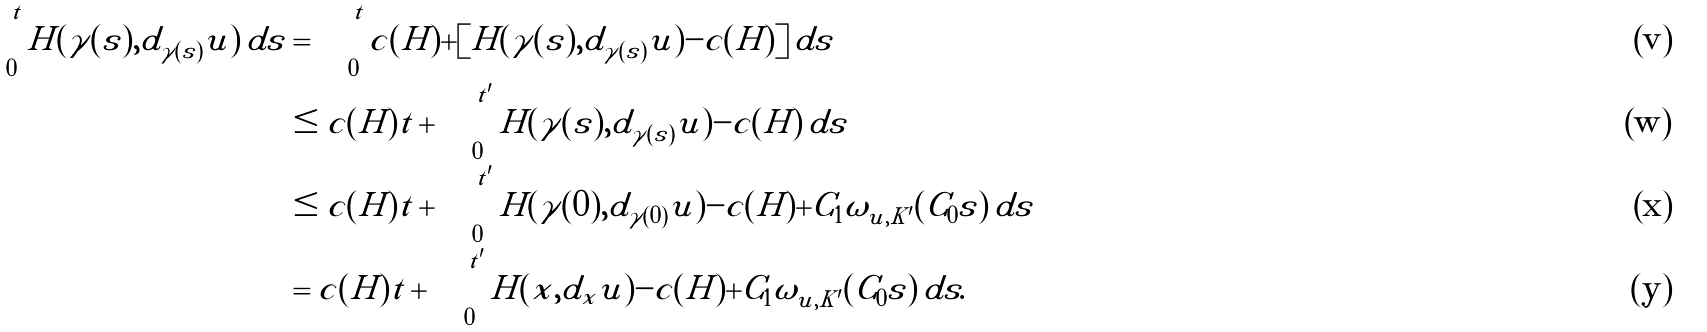Convert formula to latex. <formula><loc_0><loc_0><loc_500><loc_500>\int _ { 0 } ^ { t } H ( \gamma ( s ) , d _ { \gamma ( s ) } u ) \, d s & = \int _ { 0 } ^ { t } c ( H ) + [ H ( \gamma ( s ) , d _ { \gamma ( s ) } u ) - c ( H ) ] \, d s \\ & \leq c ( H ) t + \int _ { 0 } ^ { t ^ { \prime } } H ( \gamma ( s ) , d _ { \gamma ( s ) } u ) - c ( H ) \, d s \\ & \leq c ( H ) t + \int _ { 0 } ^ { t ^ { \prime } } H ( \gamma ( 0 ) , d _ { \gamma ( 0 ) } u ) - c ( H ) + C _ { 1 } \omega _ { u , K ^ { \prime } } ( C _ { 0 } s ) \, d s \\ & = c ( H ) t + \int _ { 0 } ^ { t ^ { \prime } } H ( x , d _ { x } u ) - c ( H ) + C _ { 1 } \omega _ { u , K ^ { \prime } } ( C _ { 0 } s ) \, d s .</formula> 